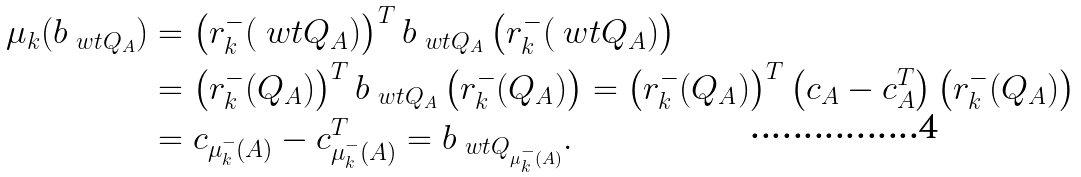<formula> <loc_0><loc_0><loc_500><loc_500>\mu _ { k } ( b _ { \ w t { Q } _ { A } } ) & = \left ( r ^ { - } _ { k } ( \ w t { Q } _ { A } ) \right ) ^ { T } b _ { \ w t { Q } _ { A } } \left ( r ^ { - } _ { k } ( \ w t { Q } _ { A } ) \right ) \\ & = \left ( r ^ { - } _ { k } ( Q _ { A } ) \right ) ^ { T } b _ { \ w t { Q } _ { A } } \left ( r ^ { - } _ { k } ( Q _ { A } ) \right ) = \left ( r ^ { - } _ { k } ( Q _ { A } ) \right ) ^ { T } \left ( c _ { A } - c _ { A } ^ { T } \right ) \left ( r ^ { - } _ { k } ( Q _ { A } ) \right ) \\ & = c _ { \mu ^ { - } _ { k } ( A ) } - c _ { \mu ^ { - } _ { k } ( A ) } ^ { T } = b _ { \ w t { Q } _ { \mu ^ { - } _ { k } ( A ) } } .</formula> 